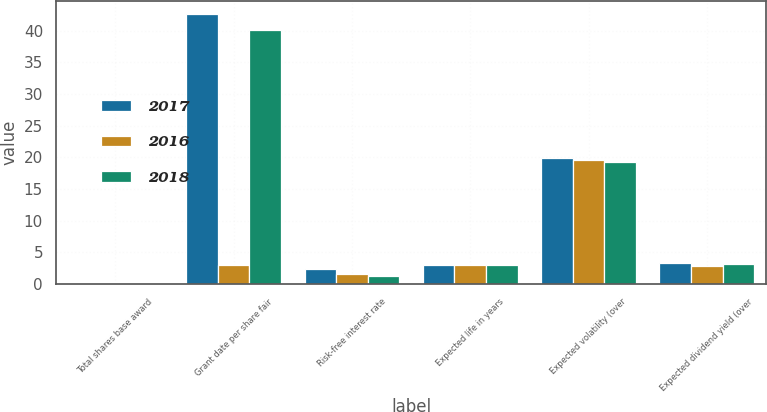<chart> <loc_0><loc_0><loc_500><loc_500><stacked_bar_chart><ecel><fcel>Total shares base award<fcel>Grant date per share fair<fcel>Risk-free interest rate<fcel>Expected life in years<fcel>Expected volatility (over<fcel>Expected dividend yield (over<nl><fcel>2017<fcel>0.1<fcel>42.6<fcel>2.4<fcel>3<fcel>19.9<fcel>3.3<nl><fcel>2016<fcel>0.1<fcel>3<fcel>1.5<fcel>3<fcel>19.5<fcel>2.8<nl><fcel>2018<fcel>0.1<fcel>40.16<fcel>1.3<fcel>3<fcel>19.2<fcel>3.1<nl></chart> 